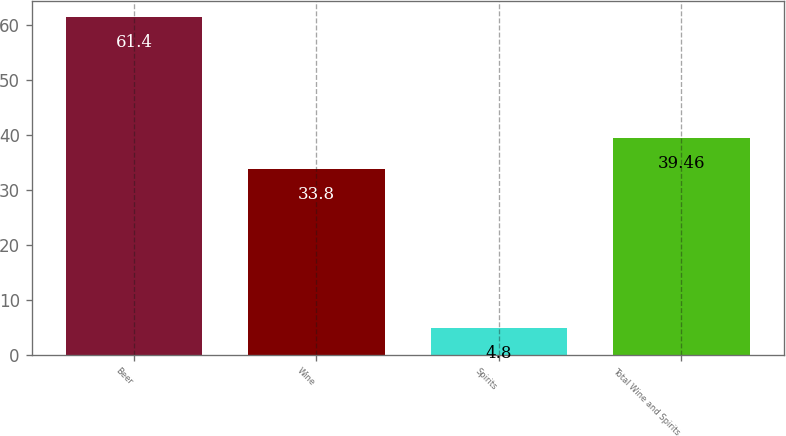Convert chart to OTSL. <chart><loc_0><loc_0><loc_500><loc_500><bar_chart><fcel>Beer<fcel>Wine<fcel>Spirits<fcel>Total Wine and Spirits<nl><fcel>61.4<fcel>33.8<fcel>4.8<fcel>39.46<nl></chart> 